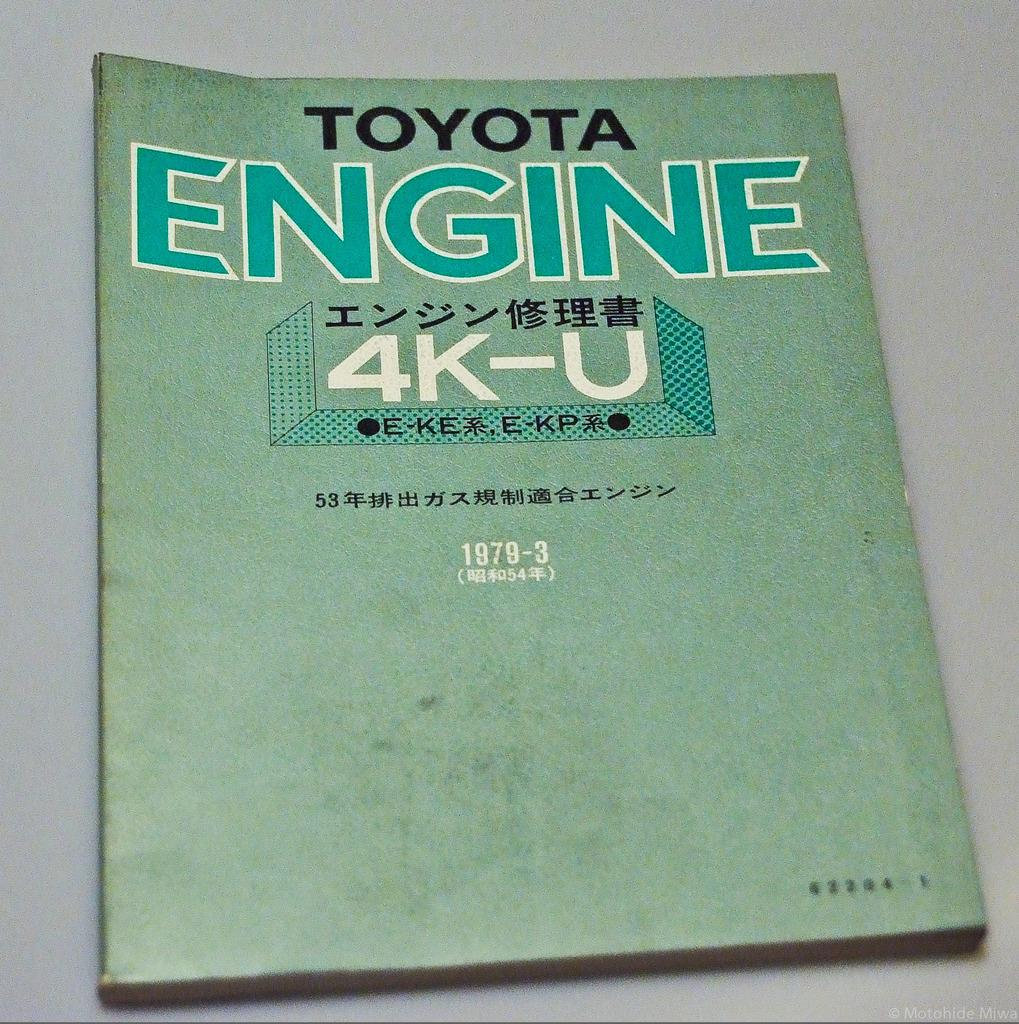What is the main subject of the image? There is a book in the center of the image. What is the color of the book? The book is in light green color. What is the book placed on? The book is on a white surface. What can be found on the book? There is text on the book. How many horses are visible in the image? There are no horses present in the image; it features a book on a white surface. What type of trees can be seen in the background of the image? There is no background or trees visible in the image, as it only shows a book on a white surface. 